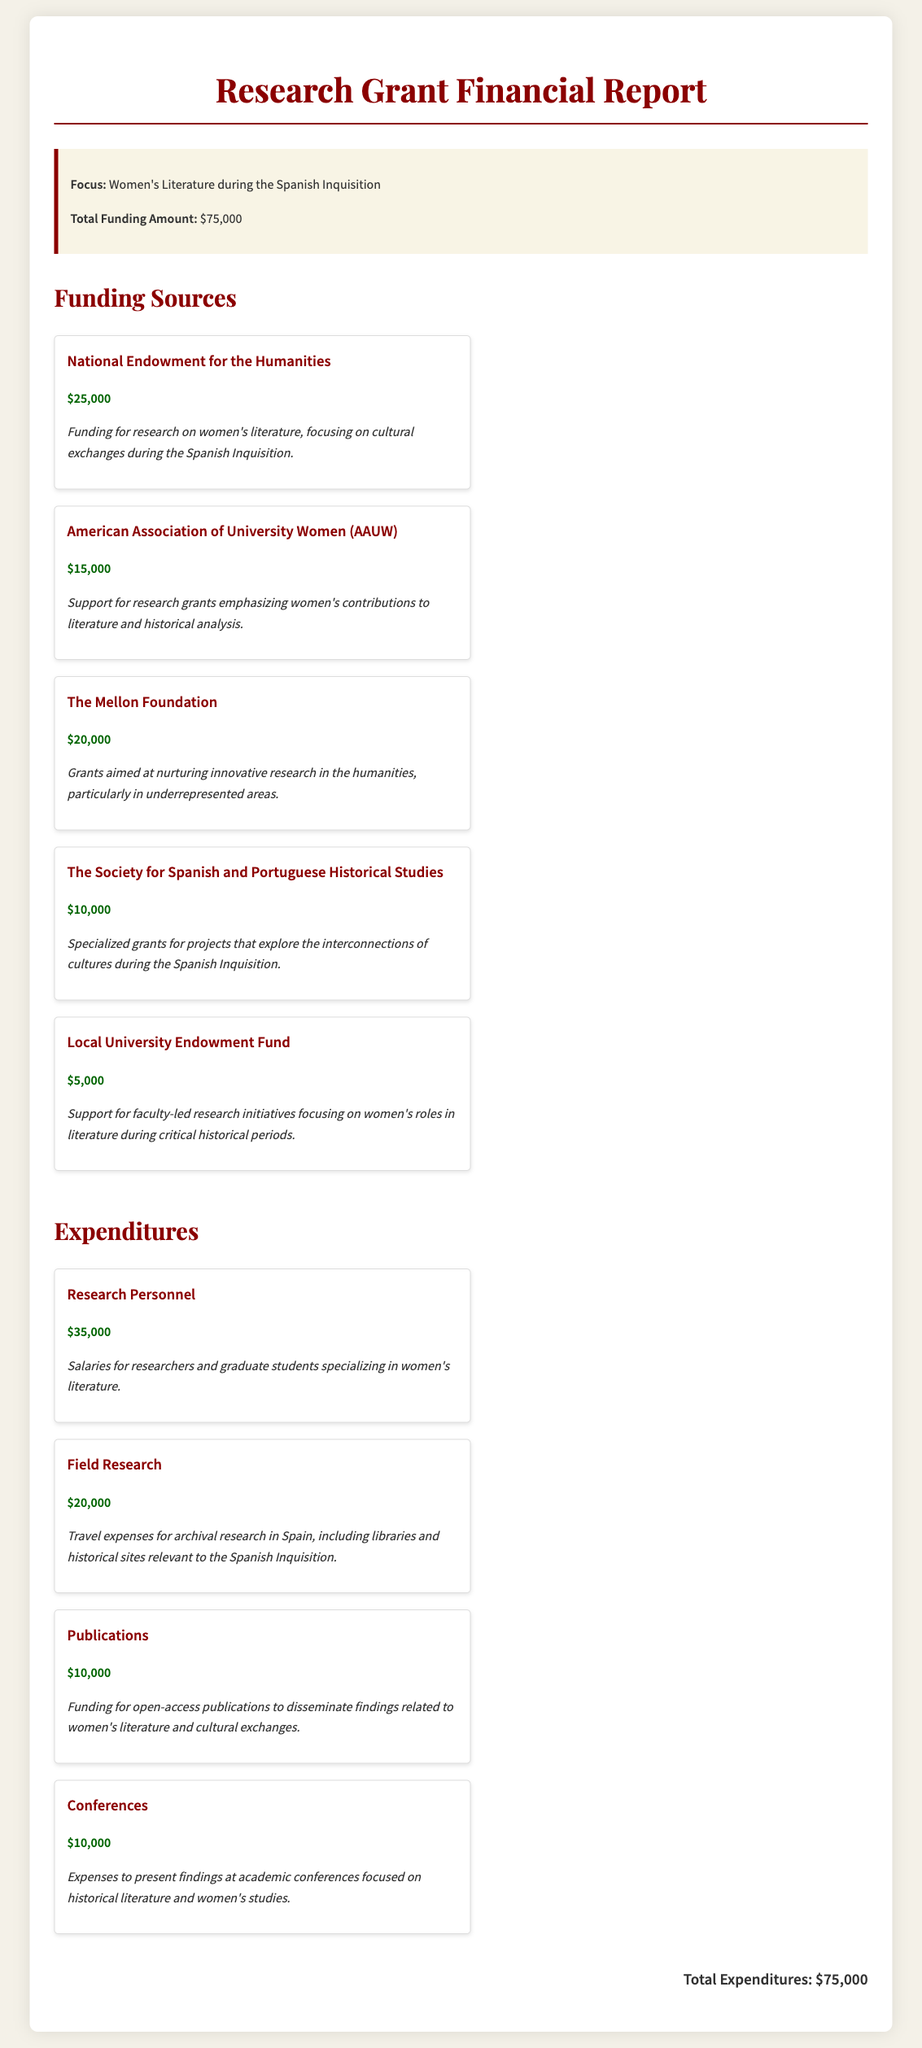What is the total funding amount? The total funding amount is clearly stated in the summary section of the document.
Answer: $75,000 Who provided the most funding? The funding sources list the National Endowment for the Humanities as the highest contributor.
Answer: National Endowment for the Humanities What is the amount allocated for field research? The expenditures section mentions the specific amount set aside for field research.
Answer: $20,000 How much is allocated for research personnel? The expenditures section states the amount designated for research personnel salaries.
Answer: $35,000 Which foundation focuses on women's contributions to literature? The document specifically mentions the American Association of University Women for this purpose.
Answer: American Association of University Women What is the total amount spent on publications? The expenditures section lists the amount dedicated to funding publications, providing a clear answer.
Answer: $10,000 How many funding sources are listed in the document? By counting the funding sources in the corresponding section, we can determine this number.
Answer: 5 What is the expenditure for conferences? The expenditure section details the specific amount reserved for conferences related to findings presentations.
Answer: $10,000 What type of research does The Mellon Foundation support? The document describes The Mellon Foundation's focus on nurturing research in underrepresented areas in the humanities.
Answer: Innovative research in the humanities 